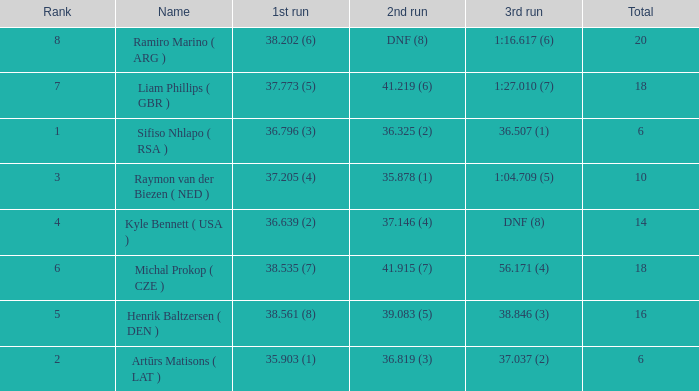Which 3rd run has rank of 1? 36.507 (1). 